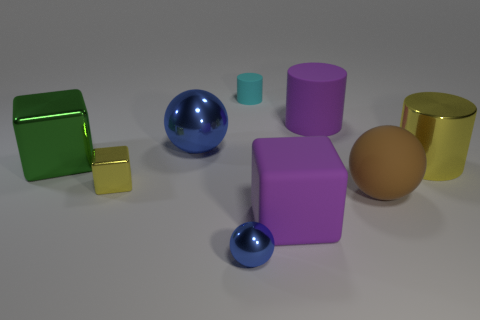There is a small object that is both behind the purple matte cube and right of the yellow block; what shape is it?
Keep it short and to the point. Cylinder. What material is the purple cylinder?
Offer a terse response. Rubber. How many cylinders are either large green things or big purple matte objects?
Your answer should be very brief. 1. Do the big yellow cylinder and the big blue ball have the same material?
Your answer should be very brief. Yes. There is a matte thing that is the same shape as the big green metallic object; what size is it?
Keep it short and to the point. Large. The small thing that is in front of the cyan thing and to the right of the large blue shiny thing is made of what material?
Your answer should be compact. Metal. Is the number of big blue spheres on the left side of the yellow cube the same as the number of balls?
Provide a short and direct response. No. What number of things are shiny spheres in front of the big yellow metallic cylinder or cylinders?
Offer a terse response. 4. There is a big block behind the large brown sphere; is it the same color as the tiny cylinder?
Keep it short and to the point. No. What size is the blue ball behind the big matte ball?
Make the answer very short. Large. 